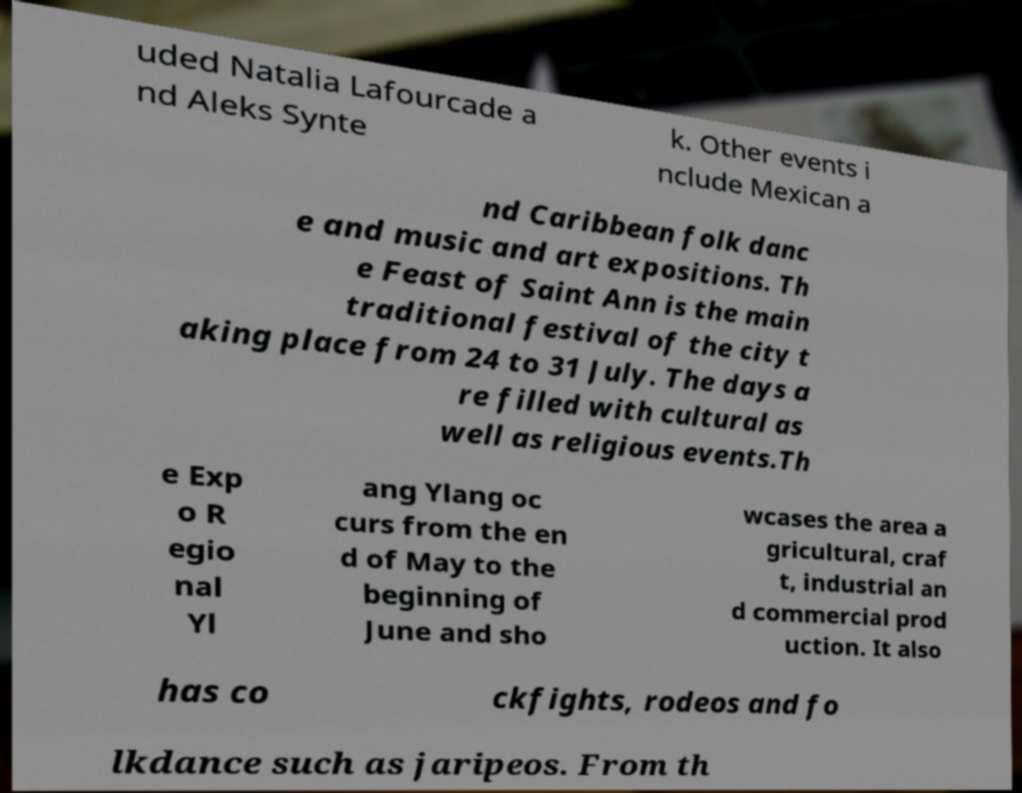Can you read and provide the text displayed in the image?This photo seems to have some interesting text. Can you extract and type it out for me? uded Natalia Lafourcade a nd Aleks Synte k. Other events i nclude Mexican a nd Caribbean folk danc e and music and art expositions. Th e Feast of Saint Ann is the main traditional festival of the city t aking place from 24 to 31 July. The days a re filled with cultural as well as religious events.Th e Exp o R egio nal Yl ang Ylang oc curs from the en d of May to the beginning of June and sho wcases the area a gricultural, craf t, industrial an d commercial prod uction. It also has co ckfights, rodeos and fo lkdance such as jaripeos. From th 